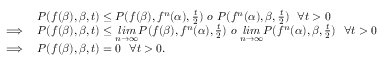Convert formula to latex. <formula><loc_0><loc_0><loc_500><loc_500>\begin{array} { r l } & { P ( f ( \beta ) , \beta , t ) \leq P ( f ( \beta ) , f ^ { n } ( \alpha ) , \frac { t } { 2 } ) o P ( f ^ { n } ( \alpha ) , \beta , \frac { t } { 2 } ) \forall t > 0 } \\ { \implies } & { P ( f ( \beta ) , \beta , t ) \leq \underset { n \rightarrow \infty } { l i m } P ( f ( \beta ) , f ^ { n } ( \alpha ) , \frac { t } { 2 } ) o \underset { n \rightarrow \infty } { l i m } P ( f ^ { n } ( \alpha ) , \beta , \frac { t } { 2 } ) \forall t > 0 } \\ { \implies } & { P ( f ( \beta ) , \beta , t ) = 0 \forall t > 0 . } \end{array}</formula> 